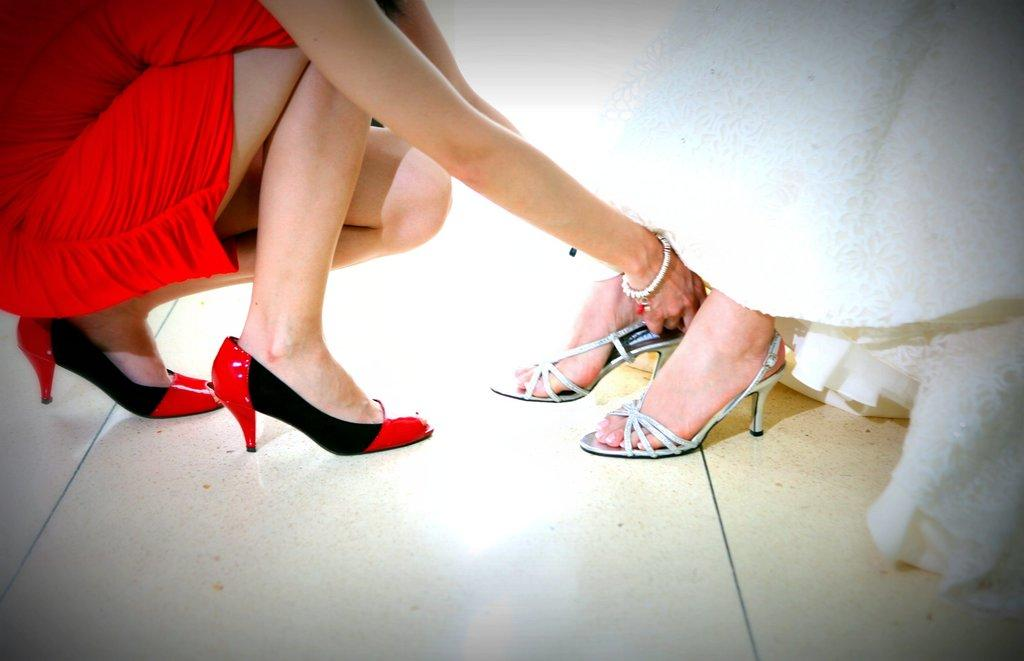Who can be seen in the image? There are people in the image. Can you describe one of the individuals in the image? There is a woman in the image. What is the woman wearing? The woman is wearing a red dress. What is the woman holding in the image? The woman is holding sandals. What type of beef is being served in the room in the image? There is no room or beef present in the image; it features a woman wearing a red dress and holding sandals. 